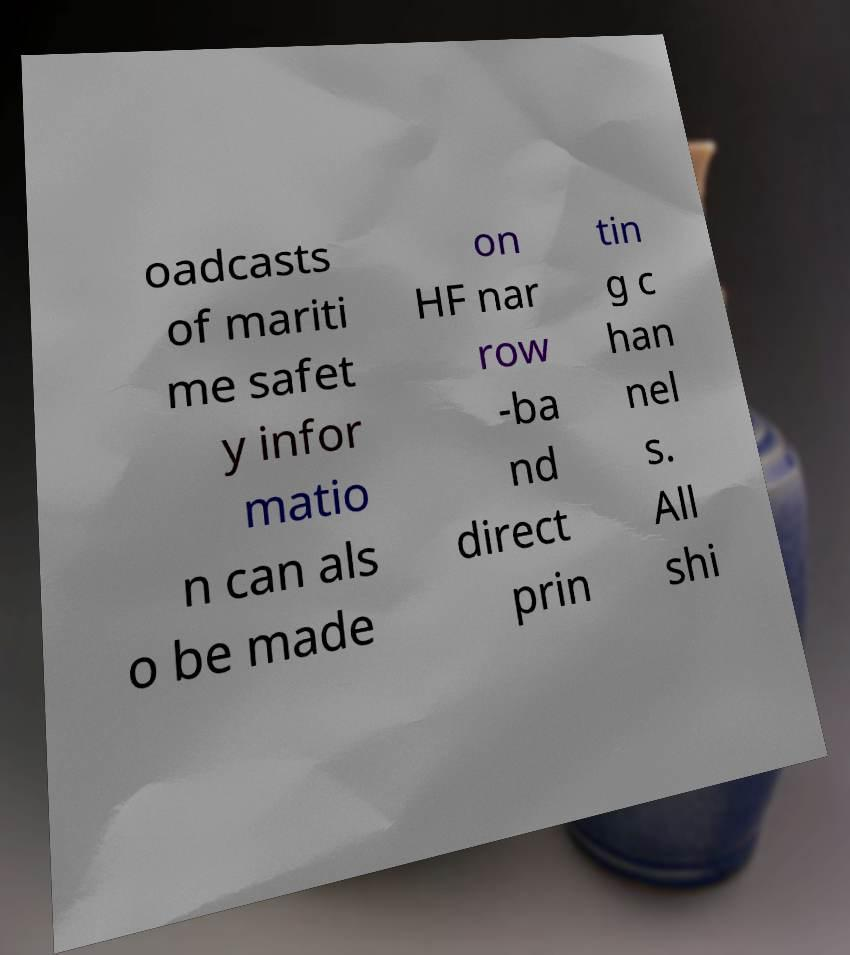I need the written content from this picture converted into text. Can you do that? oadcasts of mariti me safet y infor matio n can als o be made on HF nar row -ba nd direct prin tin g c han nel s. All shi 